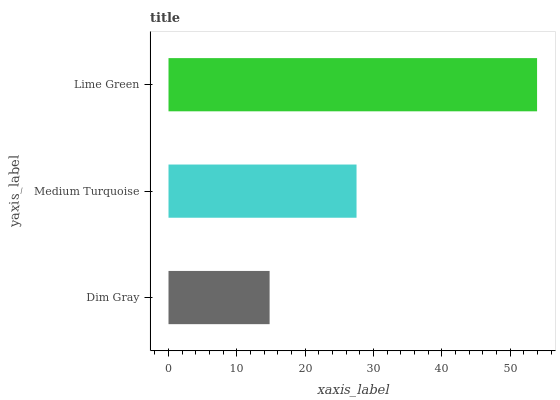Is Dim Gray the minimum?
Answer yes or no. Yes. Is Lime Green the maximum?
Answer yes or no. Yes. Is Medium Turquoise the minimum?
Answer yes or no. No. Is Medium Turquoise the maximum?
Answer yes or no. No. Is Medium Turquoise greater than Dim Gray?
Answer yes or no. Yes. Is Dim Gray less than Medium Turquoise?
Answer yes or no. Yes. Is Dim Gray greater than Medium Turquoise?
Answer yes or no. No. Is Medium Turquoise less than Dim Gray?
Answer yes or no. No. Is Medium Turquoise the high median?
Answer yes or no. Yes. Is Medium Turquoise the low median?
Answer yes or no. Yes. Is Dim Gray the high median?
Answer yes or no. No. Is Dim Gray the low median?
Answer yes or no. No. 